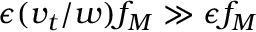<formula> <loc_0><loc_0><loc_500><loc_500>\epsilon ( v _ { t } / w ) f _ { M } \gg \epsilon f _ { M }</formula> 